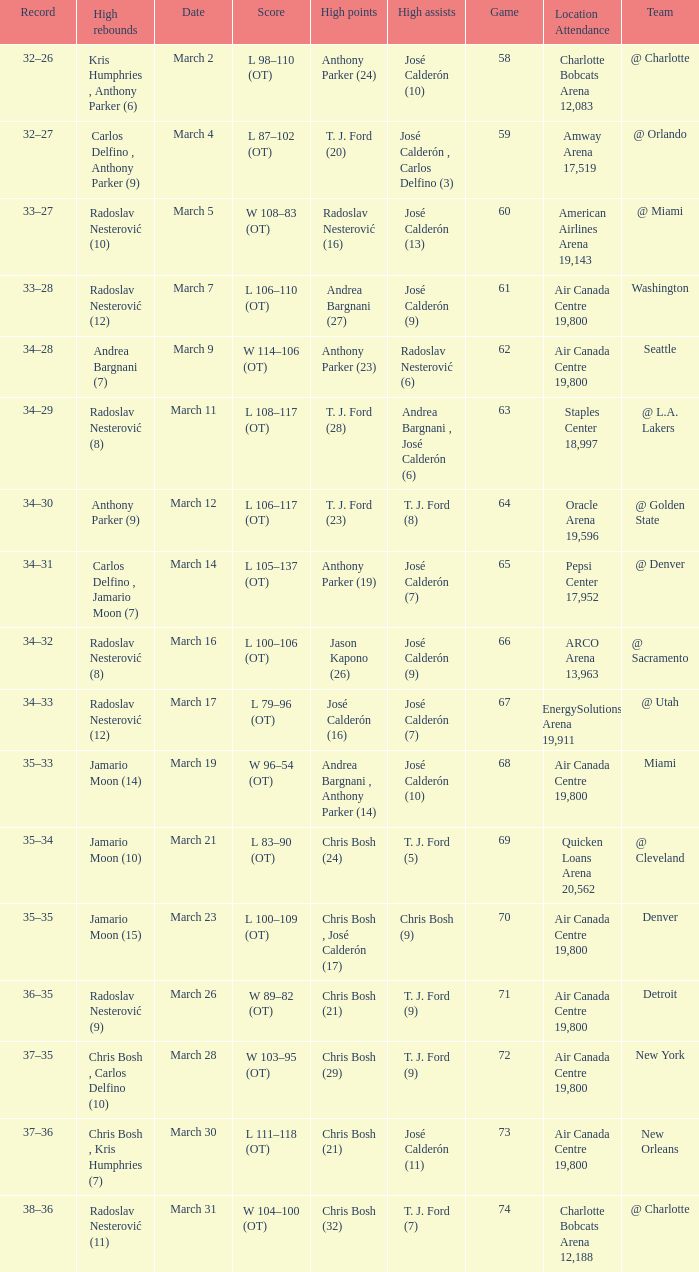What numbered game featured a High rebounds of radoslav nesterović (8), and a High assists of josé calderón (9)? 1.0. 